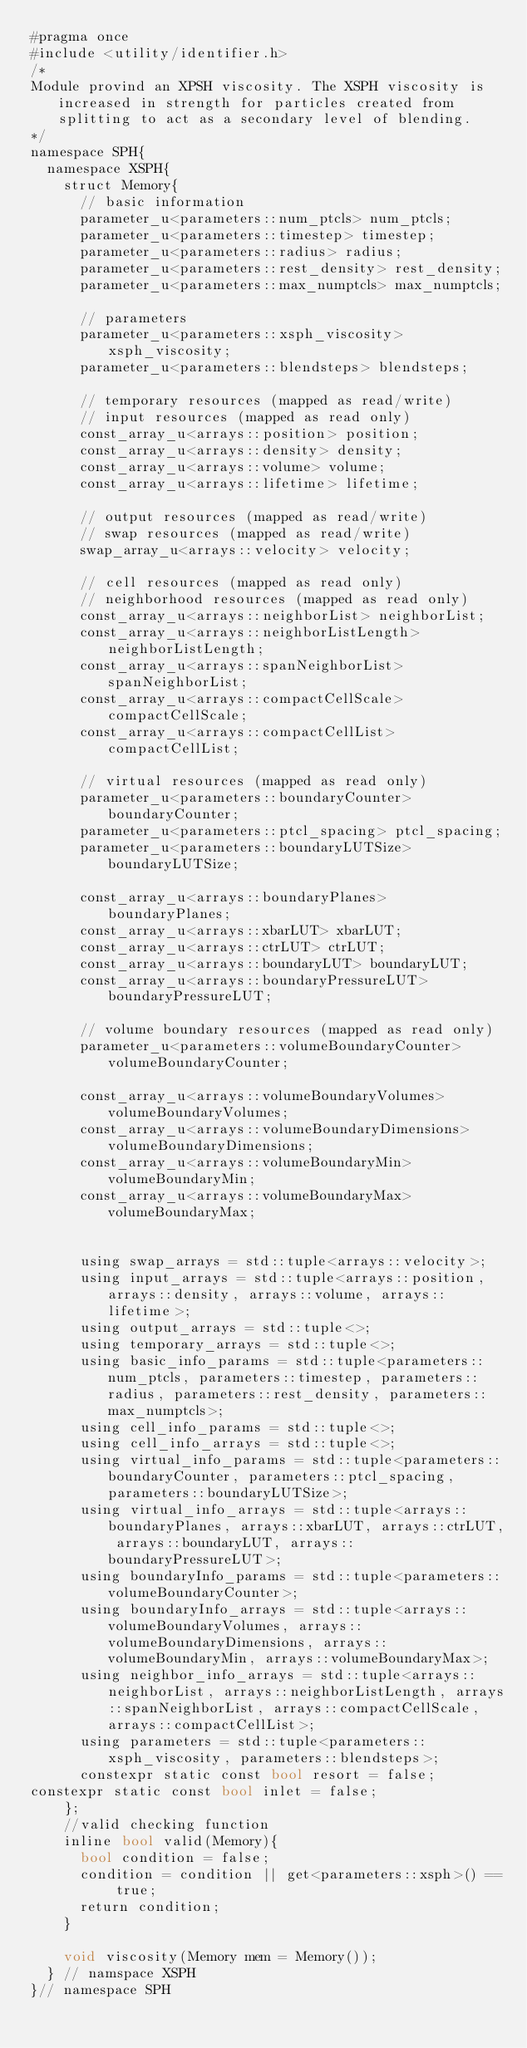Convert code to text. <code><loc_0><loc_0><loc_500><loc_500><_Cuda_>#pragma once
#include <utility/identifier.h>
/*
Module provind an XPSH viscosity. The XSPH viscosity is increased in strength for particles created from splitting to act as a secondary level of blending.
*/
namespace SPH{
	namespace XSPH{
		struct Memory{
			// basic information
			parameter_u<parameters::num_ptcls> num_ptcls;
			parameter_u<parameters::timestep> timestep;
			parameter_u<parameters::radius> radius;
			parameter_u<parameters::rest_density> rest_density;
			parameter_u<parameters::max_numptcls> max_numptcls;

			// parameters
			parameter_u<parameters::xsph_viscosity> xsph_viscosity;
			parameter_u<parameters::blendsteps> blendsteps;

			// temporary resources (mapped as read/write)
			// input resources (mapped as read only)
			const_array_u<arrays::position> position;
			const_array_u<arrays::density> density;
			const_array_u<arrays::volume> volume;
			const_array_u<arrays::lifetime> lifetime;

			// output resources (mapped as read/write)
			// swap resources (mapped as read/write)
			swap_array_u<arrays::velocity> velocity;

			// cell resources (mapped as read only)
			// neighborhood resources (mapped as read only)
			const_array_u<arrays::neighborList> neighborList;
			const_array_u<arrays::neighborListLength> neighborListLength;
			const_array_u<arrays::spanNeighborList> spanNeighborList;
			const_array_u<arrays::compactCellScale> compactCellScale;
			const_array_u<arrays::compactCellList> compactCellList;

			// virtual resources (mapped as read only)
			parameter_u<parameters::boundaryCounter> boundaryCounter;
			parameter_u<parameters::ptcl_spacing> ptcl_spacing;
			parameter_u<parameters::boundaryLUTSize> boundaryLUTSize;

			const_array_u<arrays::boundaryPlanes> boundaryPlanes;
			const_array_u<arrays::xbarLUT> xbarLUT;
			const_array_u<arrays::ctrLUT> ctrLUT;
			const_array_u<arrays::boundaryLUT> boundaryLUT;
			const_array_u<arrays::boundaryPressureLUT> boundaryPressureLUT;

			// volume boundary resources (mapped as read only)
			parameter_u<parameters::volumeBoundaryCounter> volumeBoundaryCounter;

			const_array_u<arrays::volumeBoundaryVolumes> volumeBoundaryVolumes;
			const_array_u<arrays::volumeBoundaryDimensions> volumeBoundaryDimensions;
			const_array_u<arrays::volumeBoundaryMin> volumeBoundaryMin;
			const_array_u<arrays::volumeBoundaryMax> volumeBoundaryMax;

			
			using swap_arrays = std::tuple<arrays::velocity>;
			using input_arrays = std::tuple<arrays::position, arrays::density, arrays::volume, arrays::lifetime>;
			using output_arrays = std::tuple<>;
			using temporary_arrays = std::tuple<>;
			using basic_info_params = std::tuple<parameters::num_ptcls, parameters::timestep, parameters::radius, parameters::rest_density, parameters::max_numptcls>;
			using cell_info_params = std::tuple<>;
			using cell_info_arrays = std::tuple<>;
			using virtual_info_params = std::tuple<parameters::boundaryCounter, parameters::ptcl_spacing, parameters::boundaryLUTSize>;
			using virtual_info_arrays = std::tuple<arrays::boundaryPlanes, arrays::xbarLUT, arrays::ctrLUT, arrays::boundaryLUT, arrays::boundaryPressureLUT>;
			using boundaryInfo_params = std::tuple<parameters::volumeBoundaryCounter>;
			using boundaryInfo_arrays = std::tuple<arrays::volumeBoundaryVolumes, arrays::volumeBoundaryDimensions, arrays::volumeBoundaryMin, arrays::volumeBoundaryMax>;
			using neighbor_info_arrays = std::tuple<arrays::neighborList, arrays::neighborListLength, arrays::spanNeighborList, arrays::compactCellScale, arrays::compactCellList>;
			using parameters = std::tuple<parameters::xsph_viscosity, parameters::blendsteps>;
			constexpr static const bool resort = false;
constexpr static const bool inlet = false;
		};
		//valid checking function
		inline bool valid(Memory){
			bool condition = false;
			condition = condition || get<parameters::xsph>() == true;
			return condition;
		}
		
		void viscosity(Memory mem = Memory());
	} // namspace XSPH
}// namespace SPH
</code> 